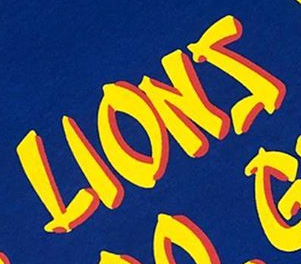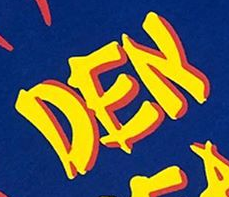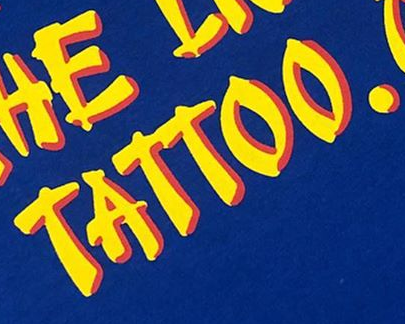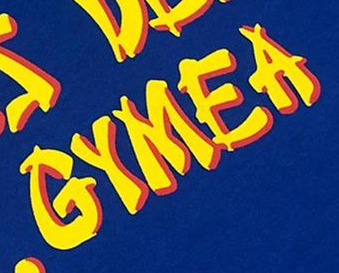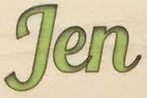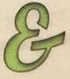What words can you see in these images in sequence, separated by a semicolon? LIONS; DEN; TATTOO.; GYMEA; Jen; & 